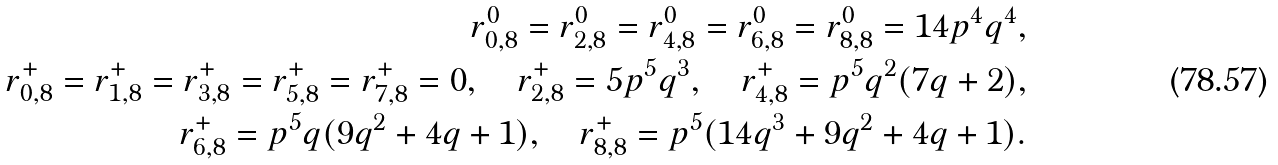<formula> <loc_0><loc_0><loc_500><loc_500>r _ { 0 , 8 } ^ { 0 } = r _ { 2 , 8 } ^ { 0 } = r _ { 4 , 8 } ^ { 0 } = r _ { 6 , 8 } ^ { 0 } = r _ { 8 , 8 } ^ { 0 } = 1 4 p ^ { 4 } q ^ { 4 } , \\ r _ { 0 , 8 } ^ { + } = r _ { 1 , 8 } ^ { + } = r _ { 3 , 8 } ^ { + } = r _ { 5 , 8 } ^ { + } = r _ { 7 , 8 } ^ { + } = 0 , \quad r _ { 2 , 8 } ^ { + } = 5 p ^ { 5 } q ^ { 3 } , \quad r _ { 4 , 8 } ^ { + } = p ^ { 5 } q ^ { 2 } ( 7 q + 2 ) , \\ r _ { 6 , 8 } ^ { + } = p ^ { 5 } q ( 9 q ^ { 2 } + 4 q + 1 ) , \quad r _ { 8 , 8 } ^ { + } = p ^ { 5 } ( 1 4 q ^ { 3 } + 9 q ^ { 2 } + 4 q + 1 ) .</formula> 